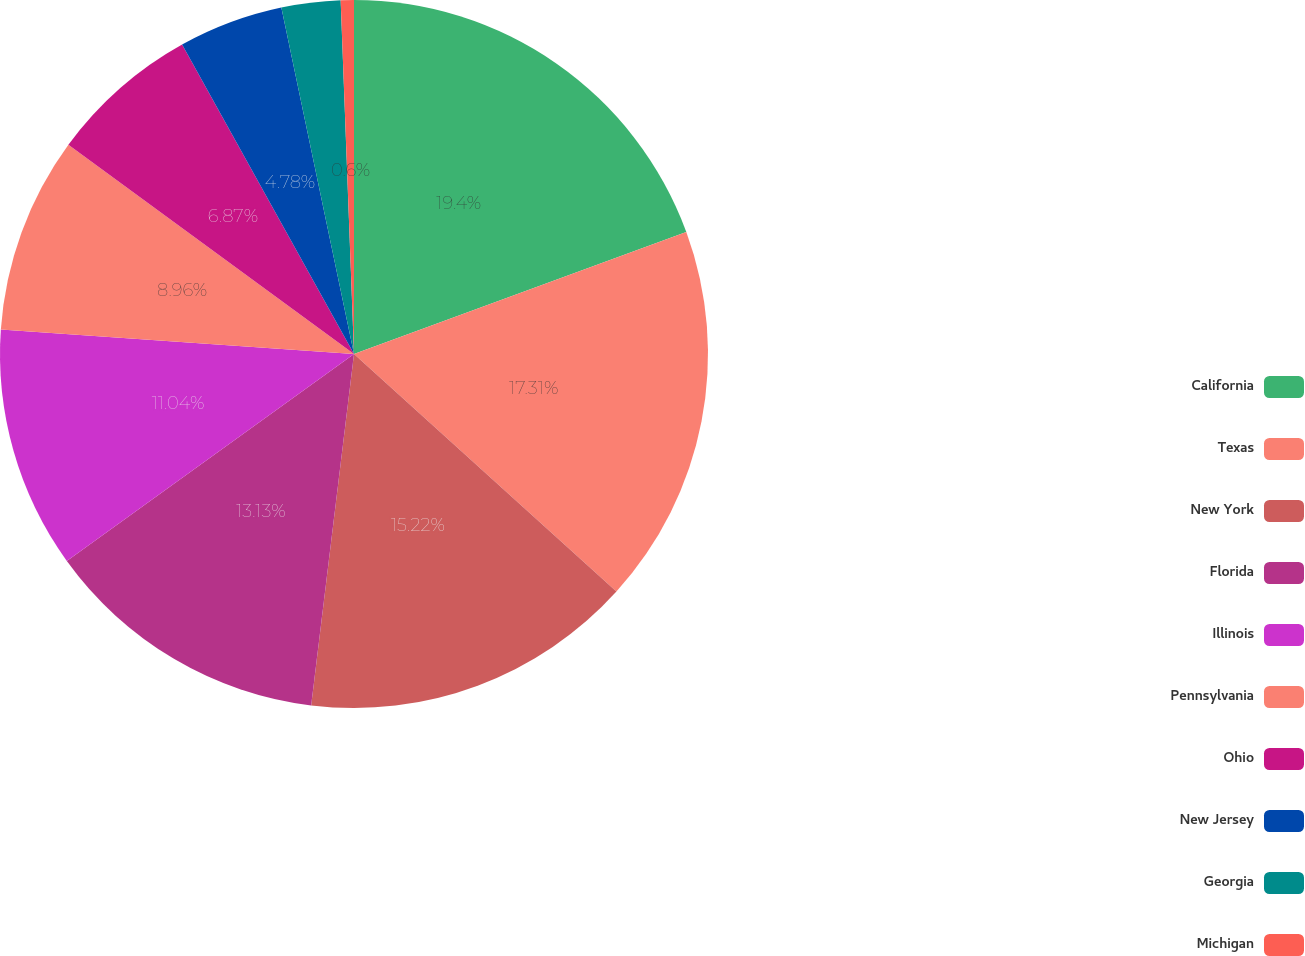<chart> <loc_0><loc_0><loc_500><loc_500><pie_chart><fcel>California<fcel>Texas<fcel>New York<fcel>Florida<fcel>Illinois<fcel>Pennsylvania<fcel>Ohio<fcel>New Jersey<fcel>Georgia<fcel>Michigan<nl><fcel>19.4%<fcel>17.31%<fcel>15.22%<fcel>13.13%<fcel>11.04%<fcel>8.96%<fcel>6.87%<fcel>4.78%<fcel>2.69%<fcel>0.6%<nl></chart> 